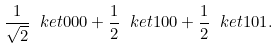<formula> <loc_0><loc_0><loc_500><loc_500>\frac { 1 } { \sqrt { 2 } } \ k e t { 0 0 0 } + \frac { 1 } { 2 } \ k e t { 1 0 0 } + \frac { 1 } { 2 } \ k e t { 1 0 1 } .</formula> 